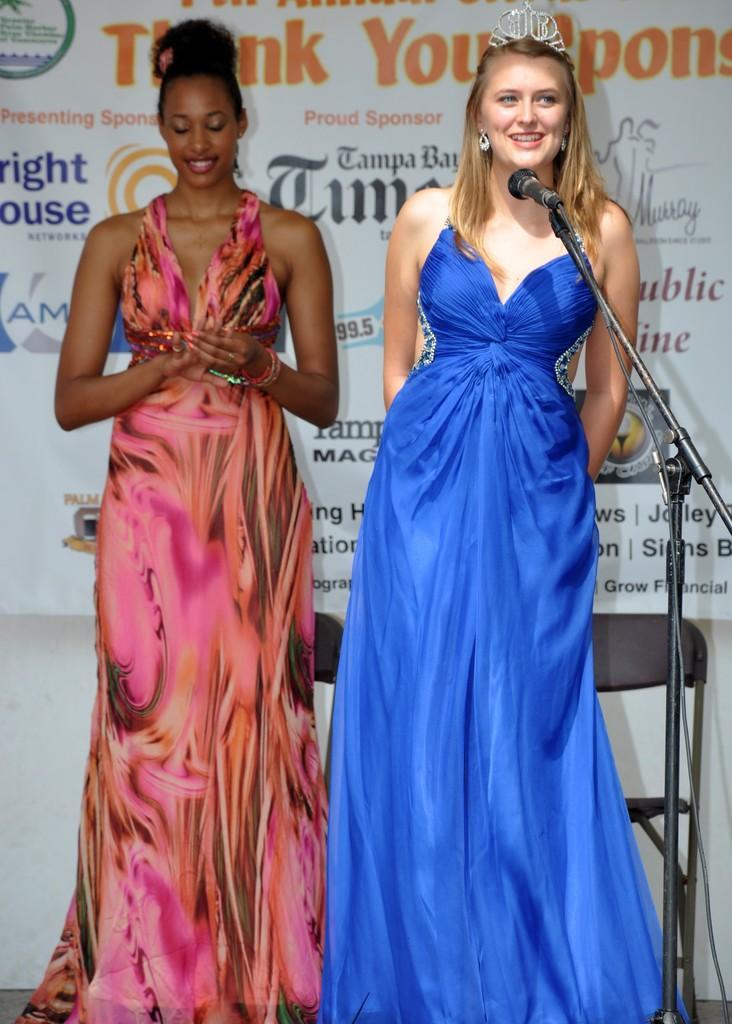Can you describe this image briefly? In this image I can see two women are standing. I can see one of them is wearing pink dress and one is wearing blue. I can also see smile on their faces and here I can see a crown on her head. I can also see a mic and and in background I can see something is written on white color thing. I can also see few chairs in background. 